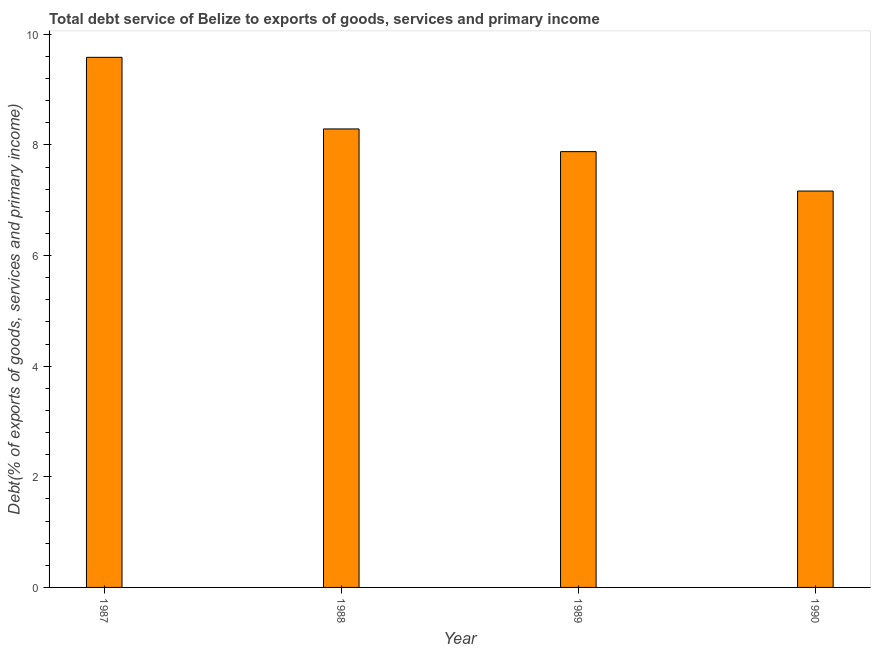Does the graph contain any zero values?
Ensure brevity in your answer.  No. What is the title of the graph?
Make the answer very short. Total debt service of Belize to exports of goods, services and primary income. What is the label or title of the X-axis?
Offer a very short reply. Year. What is the label or title of the Y-axis?
Offer a very short reply. Debt(% of exports of goods, services and primary income). What is the total debt service in 1989?
Ensure brevity in your answer.  7.88. Across all years, what is the maximum total debt service?
Provide a short and direct response. 9.58. Across all years, what is the minimum total debt service?
Offer a terse response. 7.17. In which year was the total debt service minimum?
Offer a terse response. 1990. What is the sum of the total debt service?
Offer a very short reply. 32.91. What is the difference between the total debt service in 1989 and 1990?
Make the answer very short. 0.71. What is the average total debt service per year?
Your answer should be compact. 8.23. What is the median total debt service?
Make the answer very short. 8.08. Do a majority of the years between 1988 and 1989 (inclusive) have total debt service greater than 9.2 %?
Make the answer very short. No. What is the ratio of the total debt service in 1987 to that in 1988?
Provide a succinct answer. 1.16. Is the total debt service in 1987 less than that in 1989?
Keep it short and to the point. No. Is the difference between the total debt service in 1988 and 1990 greater than the difference between any two years?
Your answer should be very brief. No. What is the difference between the highest and the second highest total debt service?
Offer a very short reply. 1.29. Is the sum of the total debt service in 1987 and 1989 greater than the maximum total debt service across all years?
Ensure brevity in your answer.  Yes. What is the difference between the highest and the lowest total debt service?
Offer a terse response. 2.42. How many bars are there?
Your answer should be compact. 4. Are all the bars in the graph horizontal?
Make the answer very short. No. What is the Debt(% of exports of goods, services and primary income) of 1987?
Ensure brevity in your answer.  9.58. What is the Debt(% of exports of goods, services and primary income) in 1988?
Your response must be concise. 8.29. What is the Debt(% of exports of goods, services and primary income) of 1989?
Give a very brief answer. 7.88. What is the Debt(% of exports of goods, services and primary income) in 1990?
Offer a terse response. 7.17. What is the difference between the Debt(% of exports of goods, services and primary income) in 1987 and 1988?
Keep it short and to the point. 1.29. What is the difference between the Debt(% of exports of goods, services and primary income) in 1987 and 1989?
Provide a succinct answer. 1.7. What is the difference between the Debt(% of exports of goods, services and primary income) in 1987 and 1990?
Keep it short and to the point. 2.42. What is the difference between the Debt(% of exports of goods, services and primary income) in 1988 and 1989?
Provide a short and direct response. 0.41. What is the difference between the Debt(% of exports of goods, services and primary income) in 1988 and 1990?
Your answer should be compact. 1.12. What is the difference between the Debt(% of exports of goods, services and primary income) in 1989 and 1990?
Your response must be concise. 0.71. What is the ratio of the Debt(% of exports of goods, services and primary income) in 1987 to that in 1988?
Offer a terse response. 1.16. What is the ratio of the Debt(% of exports of goods, services and primary income) in 1987 to that in 1989?
Make the answer very short. 1.22. What is the ratio of the Debt(% of exports of goods, services and primary income) in 1987 to that in 1990?
Offer a very short reply. 1.34. What is the ratio of the Debt(% of exports of goods, services and primary income) in 1988 to that in 1989?
Your answer should be very brief. 1.05. What is the ratio of the Debt(% of exports of goods, services and primary income) in 1988 to that in 1990?
Keep it short and to the point. 1.16. What is the ratio of the Debt(% of exports of goods, services and primary income) in 1989 to that in 1990?
Make the answer very short. 1.1. 